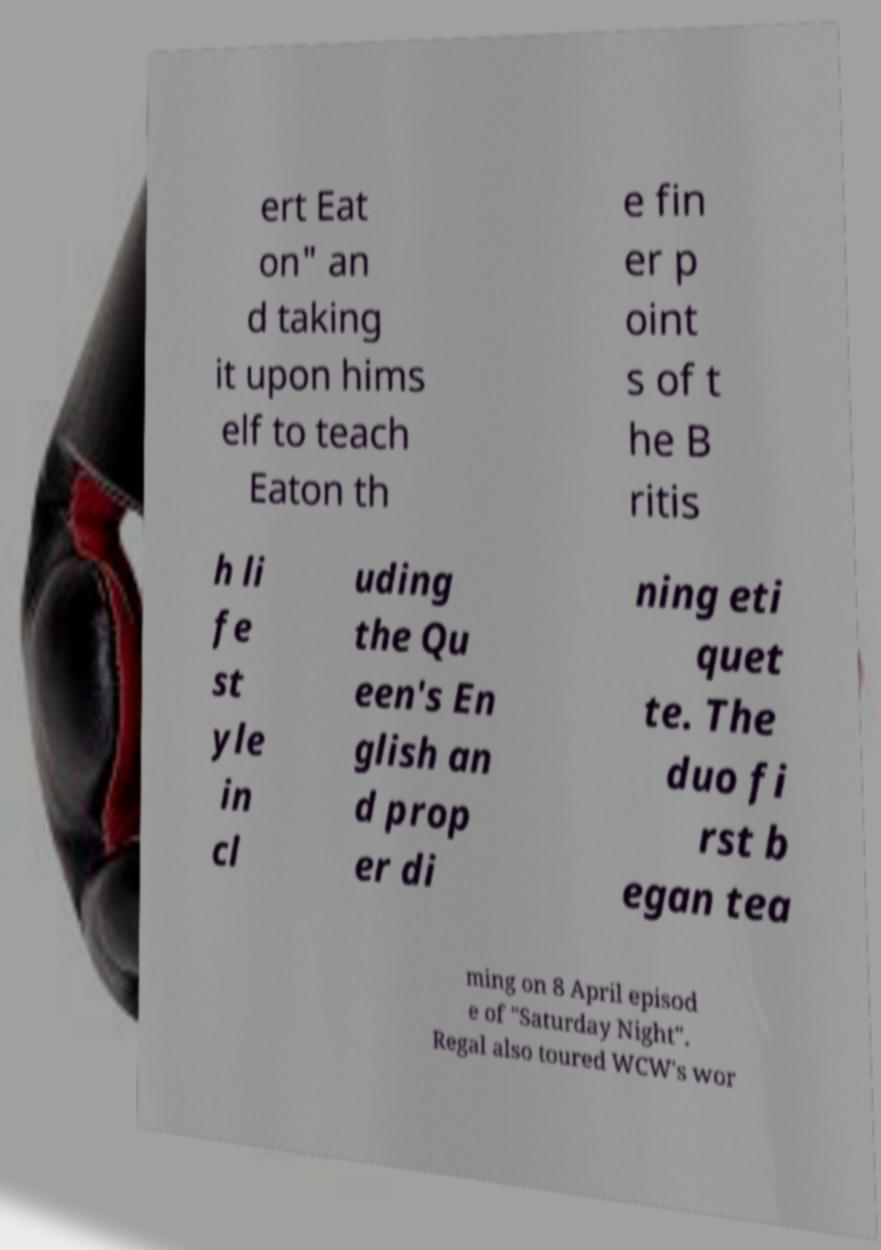For documentation purposes, I need the text within this image transcribed. Could you provide that? ert Eat on" an d taking it upon hims elf to teach Eaton th e fin er p oint s of t he B ritis h li fe st yle in cl uding the Qu een's En glish an d prop er di ning eti quet te. The duo fi rst b egan tea ming on 8 April episod e of "Saturday Night". Regal also toured WCW's wor 